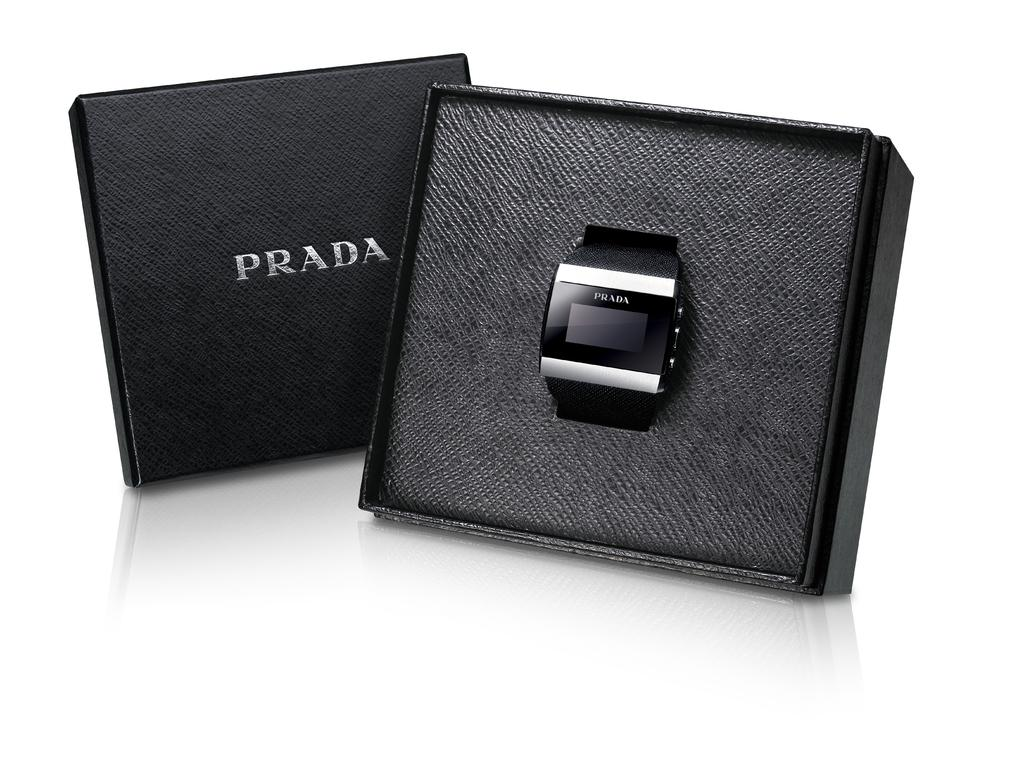<image>
Create a compact narrative representing the image presented. An electronic watch with Prada written on it sits in a black box that has a cover that also says Prada. 